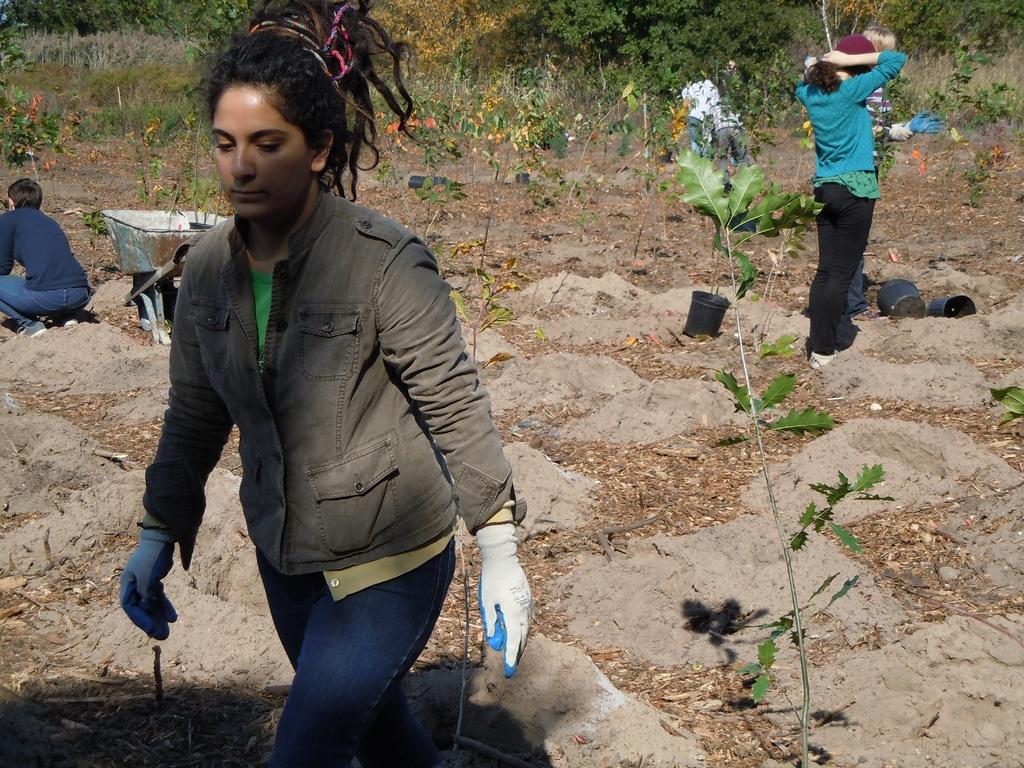What is happening in the front of the image? There is a woman walking in the front of the image, and there is a plant nearby. What can be seen in the background of the image? In the background, there are persons standing, persons sitting, trees, and plants. How many types of plants are visible in the image? There are two types of plants visible in the image: one in the front and others in the background. Is the area in the image known for its quiet grassy fields? The provided facts do not mention any information about the area being quiet or grassy fields, so we cannot confirm or deny this statement. 